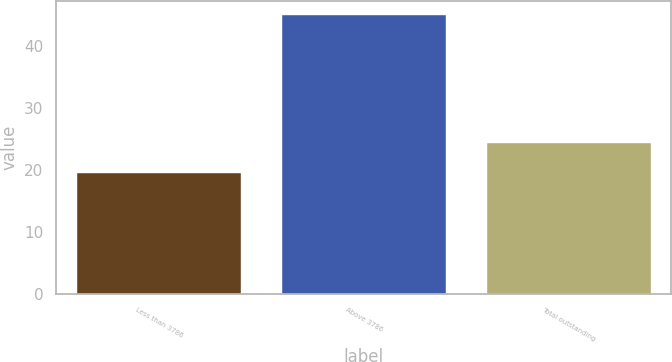Convert chart to OTSL. <chart><loc_0><loc_0><loc_500><loc_500><bar_chart><fcel>Less than 3786<fcel>Above 3786<fcel>Total outstanding<nl><fcel>19.59<fcel>45.1<fcel>24.42<nl></chart> 